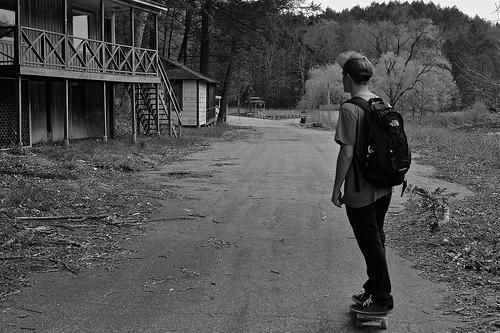How many people are there?
Give a very brief answer. 1. 